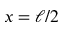Convert formula to latex. <formula><loc_0><loc_0><loc_500><loc_500>x = \ell / 2</formula> 